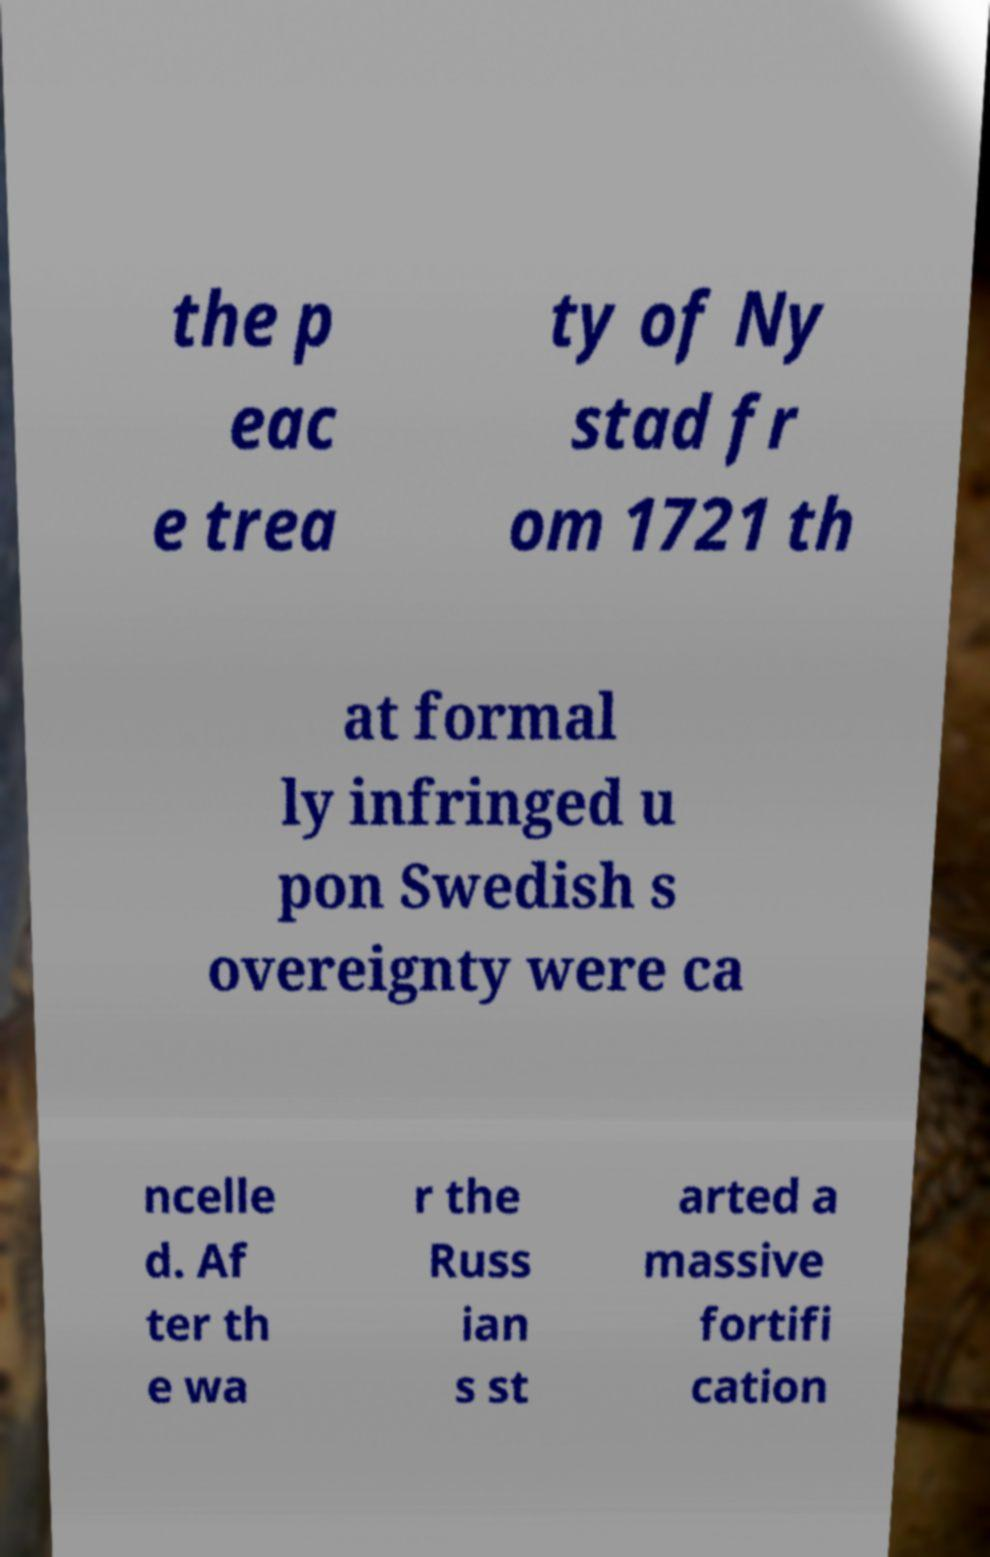Can you read and provide the text displayed in the image?This photo seems to have some interesting text. Can you extract and type it out for me? the p eac e trea ty of Ny stad fr om 1721 th at formal ly infringed u pon Swedish s overeignty were ca ncelle d. Af ter th e wa r the Russ ian s st arted a massive fortifi cation 